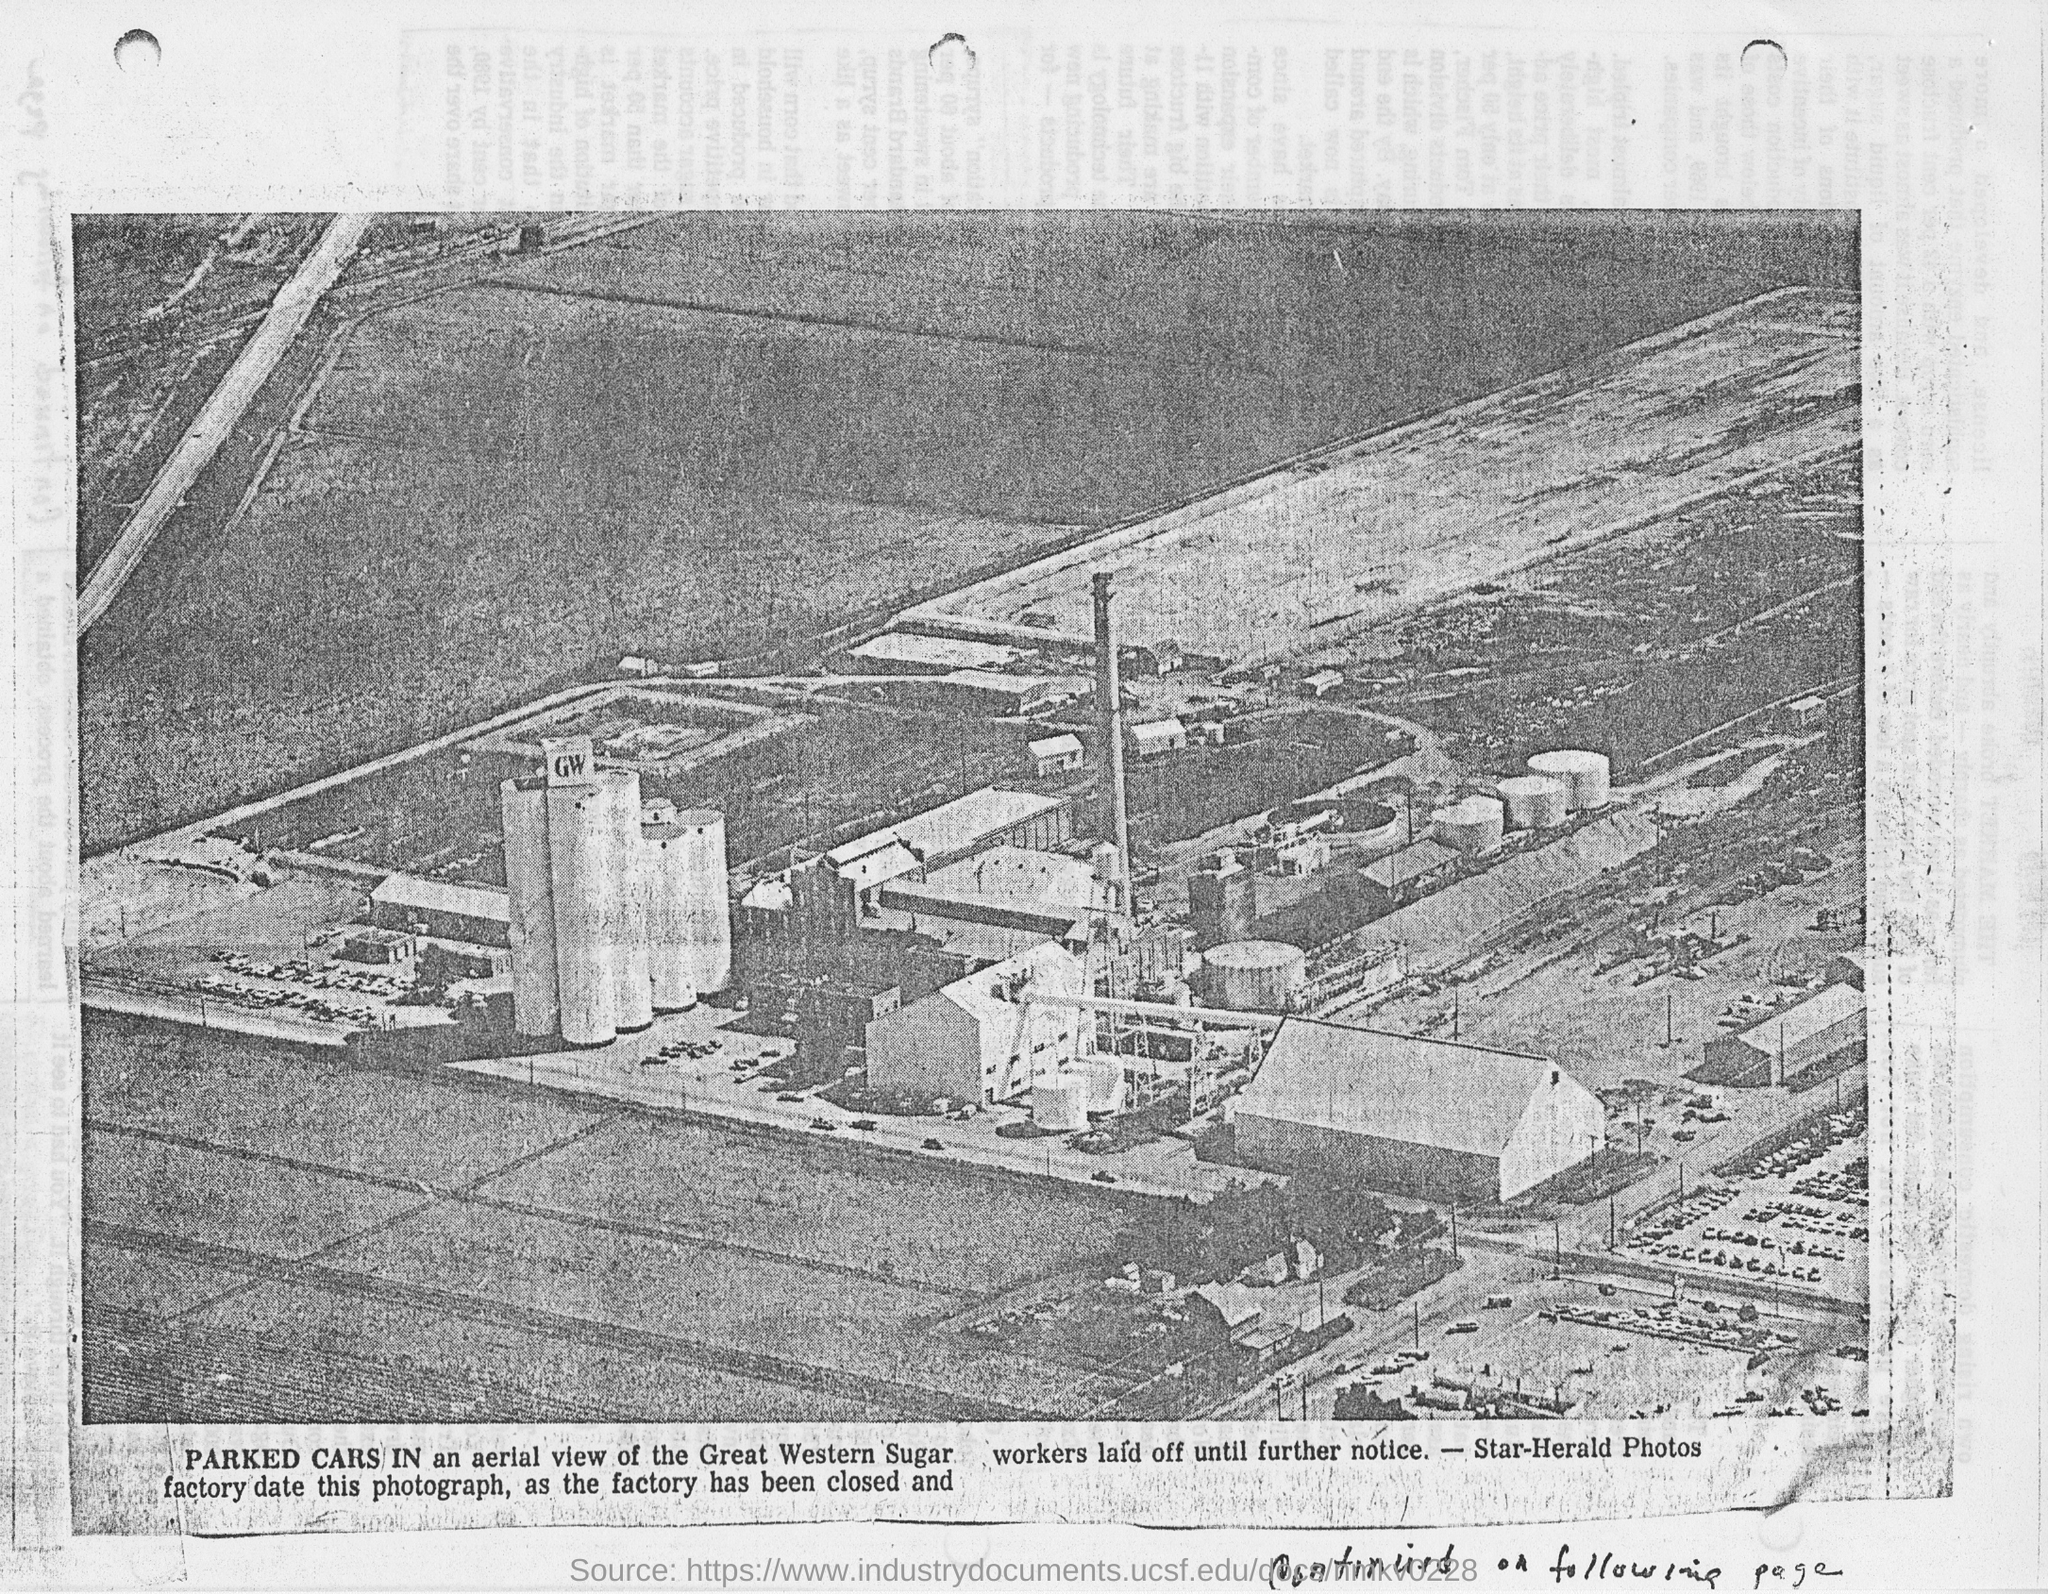Highlight a few significant elements in this photo. The aerial view in the photo belongs to the Great Western Sugar company. 